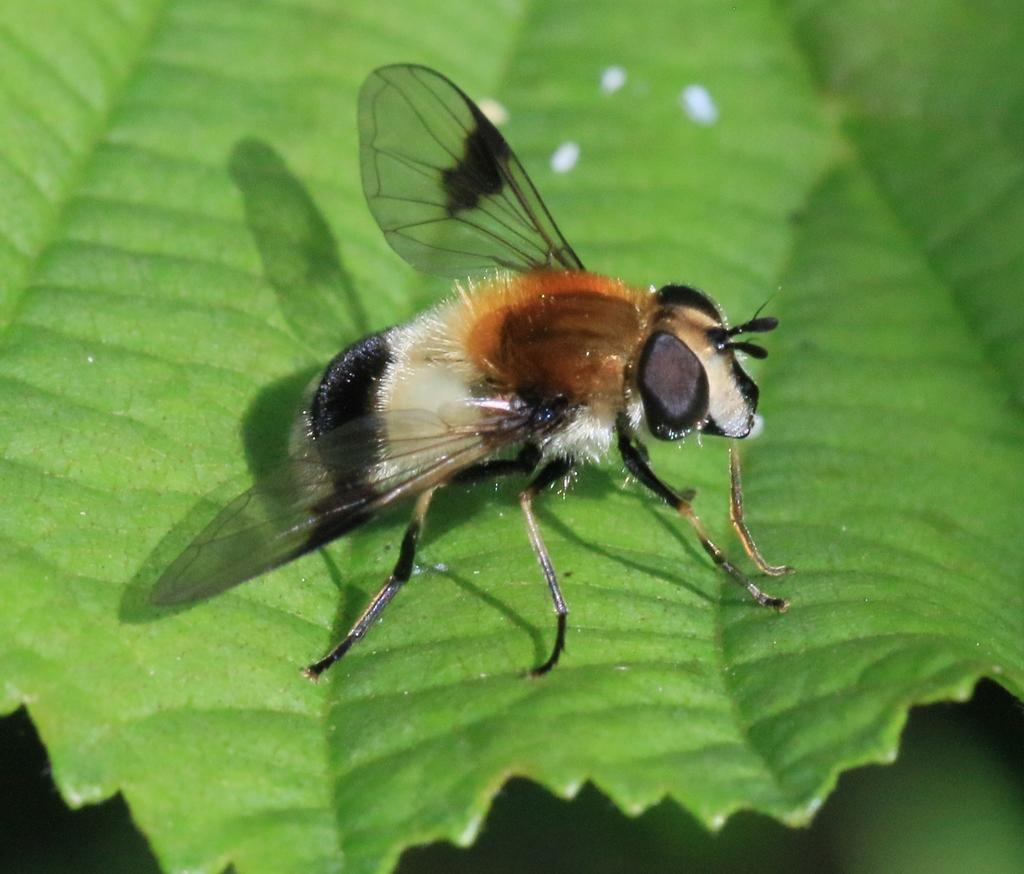What is present on the leaf in the image? There is an insect on the leaf in the image. Can you describe the insect's appearance? The insect has black, silver, and light brown colors. What is the primary subject of the image? The primary subject of the image is the insect on the leaf. Where is the cemetery located in the image? There is no cemetery present in the image; it features a leaf with an insect on it. What type of desk is visible in the image? There is no desk present in the image. 